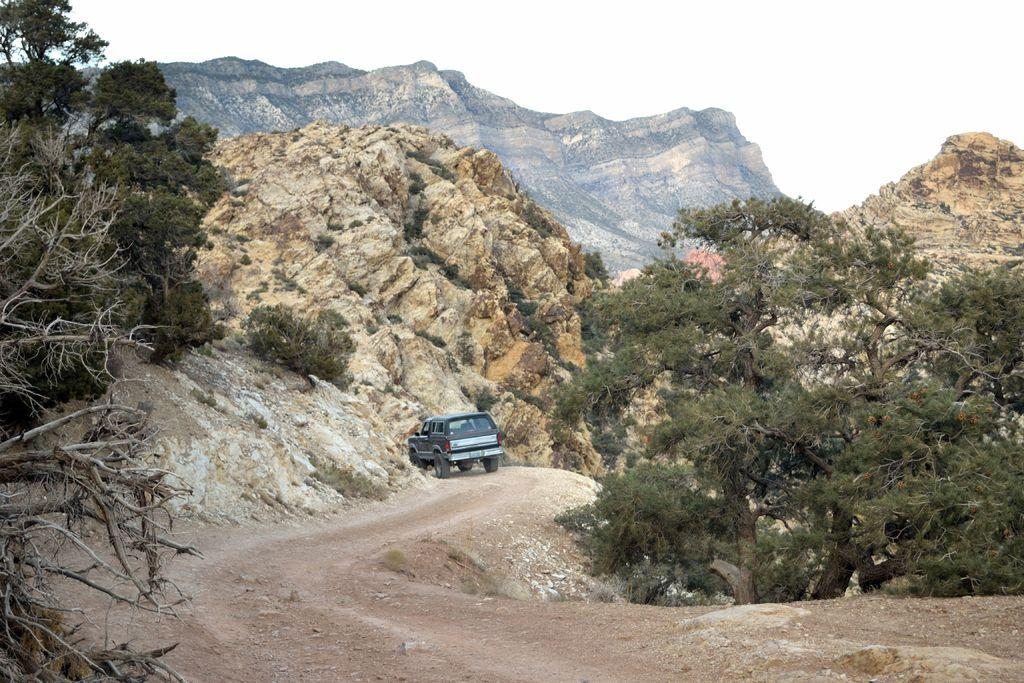What is on the road in the image? There is a vehicle on the road in the image. What type of natural elements can be seen in the image? There are trees and mountains visible in the image. What is visible in the background of the image? The sky is visible in the background of the image. What type of pies are being served on the mountains in the image? There are no pies present in the image, and the mountains are not serving any food. 